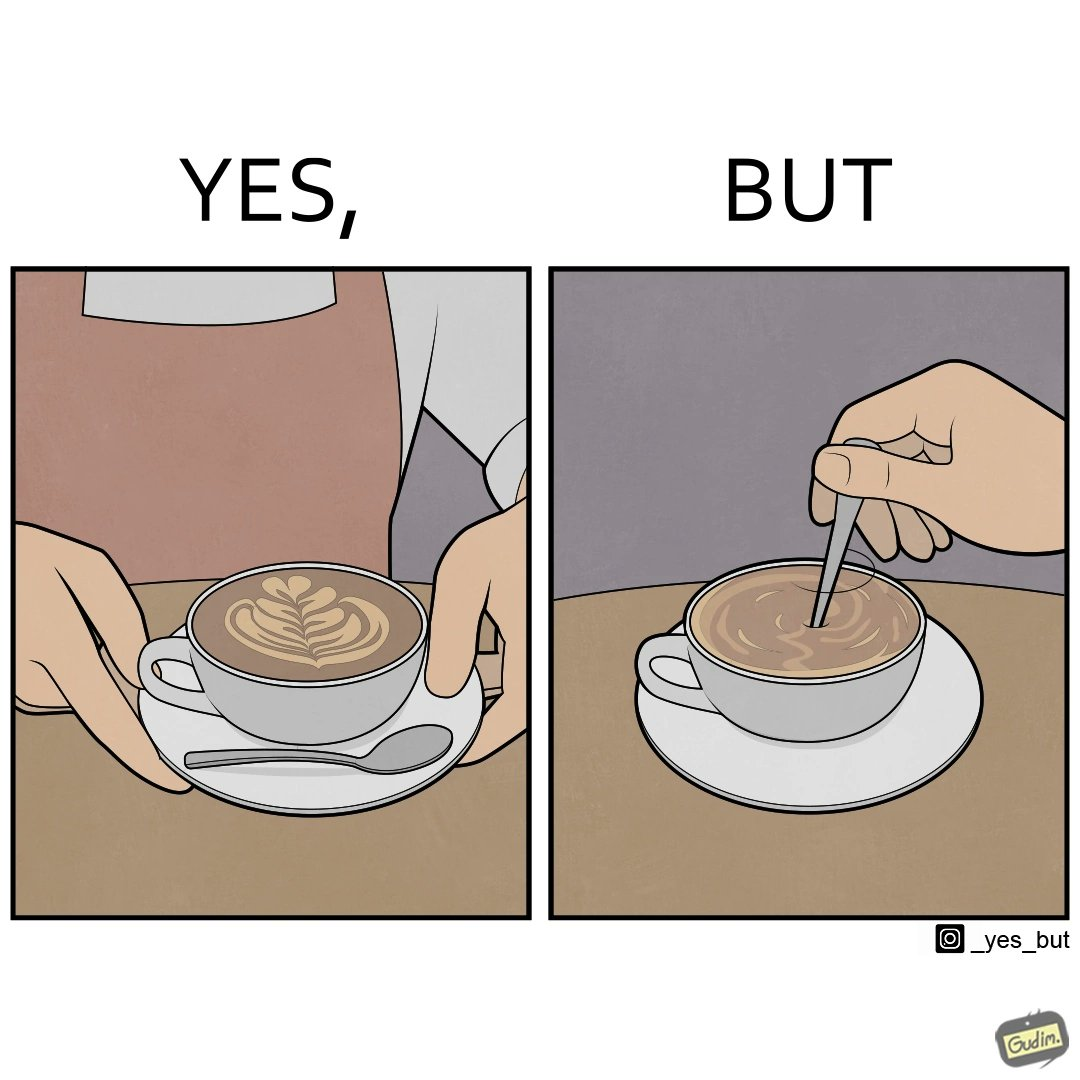Provide a description of this image. The image is ironic, because even when the coffee maker create latte art to make coffee look attractive but it is there just for a short time after that it is vanished 